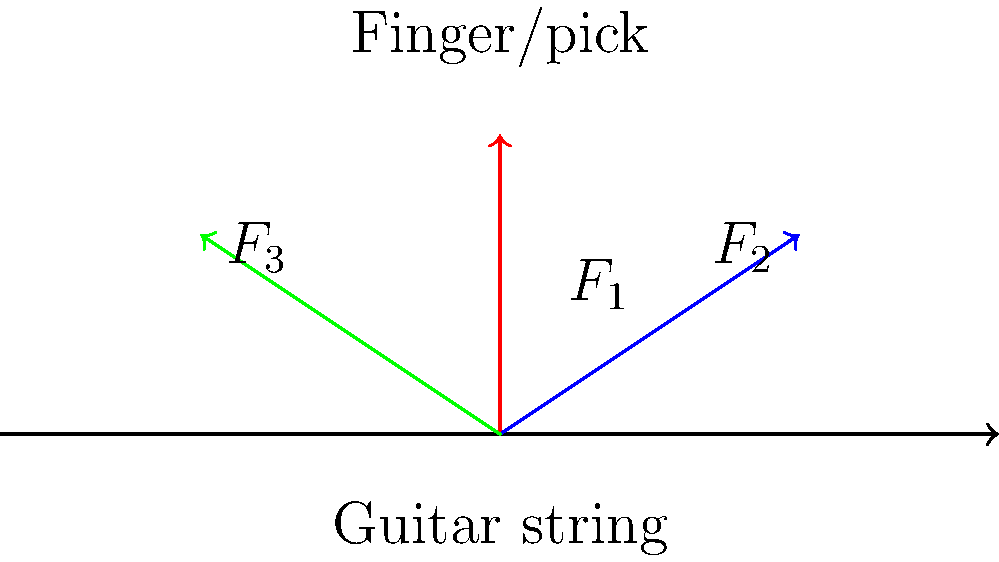As a songwriter who understands the physics of guitar playing, analyze the force vectors involved in strumming a guitar string. If the vertical force $F_1$ is 2N and the horizontal forces $F_2$ and $F_3$ are each 1.5N, what is the magnitude of the resultant force vector acting on the string? To find the magnitude of the resultant force vector, we need to follow these steps:

1) Identify the components:
   Vertical force: $F_1 = 2$ N
   Horizontal forces: $F_2 = F_3 = 1.5$ N

2) Calculate the net horizontal force:
   $F_x = F_2 - F_3 = 1.5 - 1.5 = 0$ N
   (The horizontal forces cancel each other out)

3) The net vertical force is simply $F_1$:
   $F_y = F_1 = 2$ N

4) Use the Pythagorean theorem to calculate the magnitude of the resultant force:
   $F_{resultant} = \sqrt{F_x^2 + F_y^2}$

5) Substitute the values:
   $F_{resultant} = \sqrt{0^2 + 2^2}$

6) Simplify:
   $F_{resultant} = \sqrt{4} = 2$ N

Therefore, the magnitude of the resultant force vector acting on the string is 2 N.
Answer: 2 N 